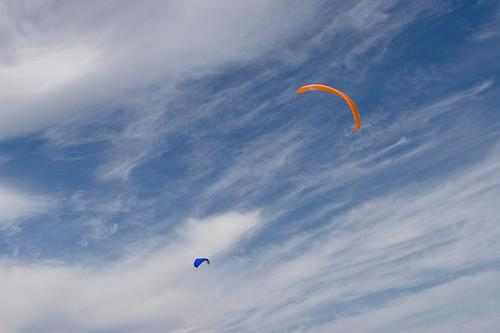Describe the scene as if you were narrating it to someone who is unable to see the image. Imagine a bright blue sky filled with a variety of white clouds, with two kites, one orange and one blue, flying gracefully above. Explain what the man in the image is doing and what he is holding. There is no man visible in the image; it only shows two kites flying in the sky. Provide a brief overview of the primary elements seen in the image. The image showcases a bright blue sky with streaks of white clouds and two kites, one orange and one blue. Give an artistic interpretation of the image. The image captures a fleeting moment of freedom and joy, with kites dancing in the air, amidst a sky adorned with clouds. Summarize the main components of the image in a single sentence. The image comprises a bright blue sky, white clouds, and two colorful kites. Explain how the sky and cloud formations contribute to the composition of the image. The vibrant blue sky, interspersed with the white clouds' various shapes and sizes, creates a serene and dynamic backdrop, enhancing the kites' presence in the scene. Provide a description that focuses on the kites' details, including their colors, logos, and undersides. The image features two kites, one orange and one blue, flying in the sky; there are no visible logos or details of their undersides. Describe the appearance of the sky in the image. The sky has a blue backdrop with white clouds dispersed throughout, with some areas of bright blue visible between the clouds. Describe the types of clouds seen in the sky in the image. There are large and small puffy white clouds and thin stringy clouds scattered across the crisp blue sky backdrop. Mention the colors and shapes of the kites and their position in the image. The picture shows two curved kites in the sky, one bright orange and the other blue, both flying among white clouds. 